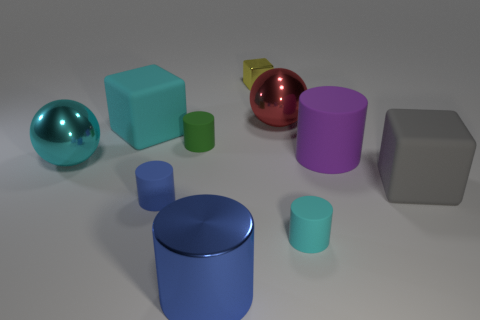Is there a pattern to the arrangement of these objects? At first glance, the objects appear randomly placed; however, upon closer inspection, one might suggest a subtle pattern where objects of similar shapes are situated in proximity, hinting at an intentional, albeit relaxed, form of organization. 